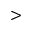Convert formula to latex. <formula><loc_0><loc_0><loc_500><loc_500>></formula> 